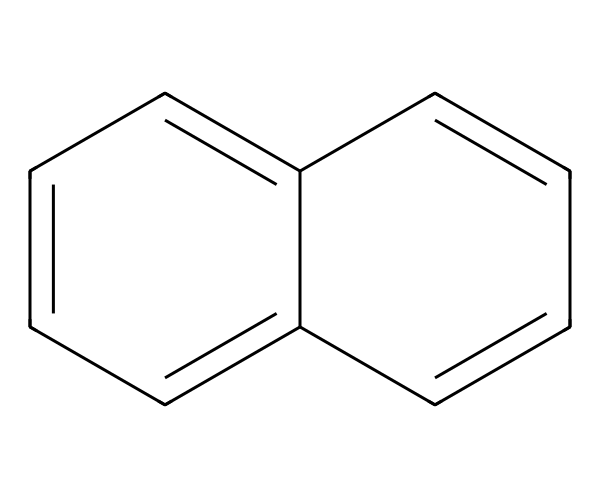What is the molecular formula of naphthalene? By examining the structure represented by the SMILES string, we can count the number of carbon and hydrogen atoms. The structure shows two fused benzene rings, contributing a total of 10 carbon atoms and 8 hydrogen atoms. Thus, the molecular formula is C10H8.
Answer: C10H8 How many aromatic rings are present in naphthalene? The SMILES representation indicates two interconnected aromatic rings, which can be identified by the alternating double bonds typical of aromatic compounds. This confirms that there are two distinct aromatic rings present.
Answer: 2 What type of chemical compound is naphthalene? Naphthalene is classified as an aromatic hydrocarbon due to its structure characterized by conjugated double bonds and the presence of a stable cyclic arrangement of carbon atoms.
Answer: aromatic hydrocarbon What is the common use of naphthalene in household items? Naphthalene is widely recognized for its use in mothballs, which are designed to repel moths and protect clothing, such as vintage band costumes, from moth damage.
Answer: mothballs Does naphthalene exhibit planar geometry? The arrangement of atoms in the naphthalene structure shows that all the carbon atoms are in a single plane, a characteristic feature of aromatic compounds, allowing for effective overlap of p-orbitals.
Answer: yes What is the total number of hydrogen atoms bonded to naphthalene? By analyzing the structure, for each of the 10 carbon atoms in naphthalene, we find there are 8 hydrogen atoms bonded to them collectively, which is consistent with its molecular formula.
Answer: 8 